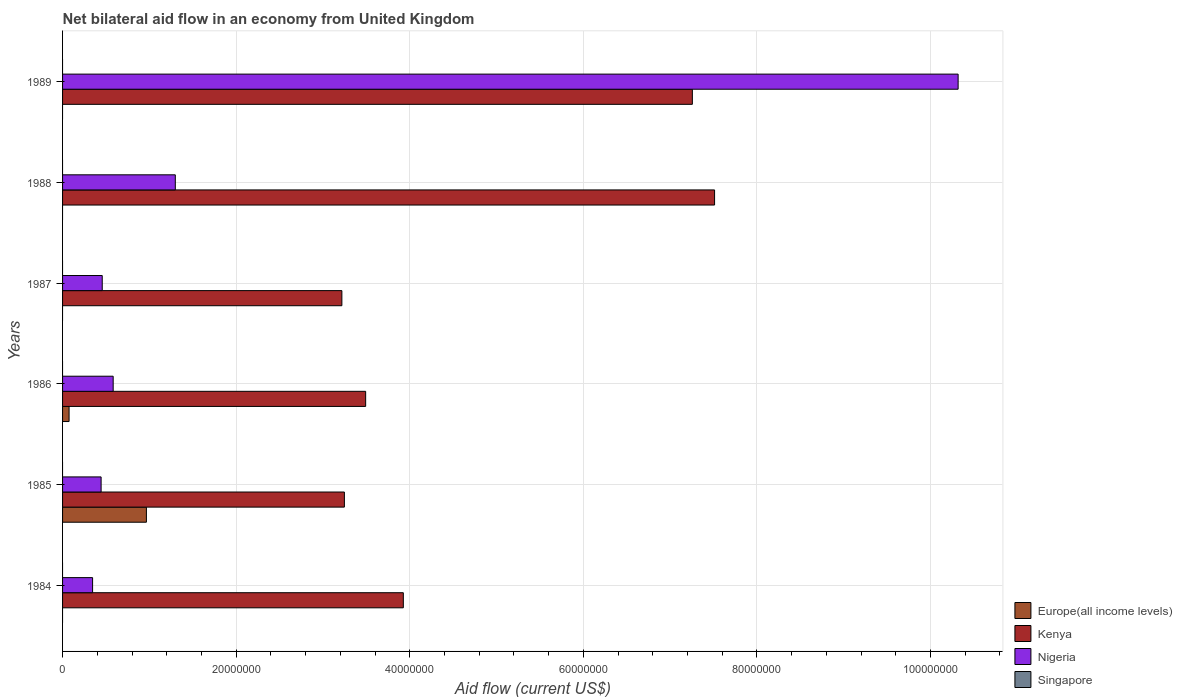How many different coloured bars are there?
Offer a very short reply. 3. How many groups of bars are there?
Keep it short and to the point. 6. Are the number of bars on each tick of the Y-axis equal?
Offer a terse response. No. Across all years, what is the maximum net bilateral aid flow in Kenya?
Your response must be concise. 7.51e+07. Across all years, what is the minimum net bilateral aid flow in Nigeria?
Give a very brief answer. 3.46e+06. What is the total net bilateral aid flow in Singapore in the graph?
Your answer should be compact. 0. What is the difference between the net bilateral aid flow in Nigeria in 1986 and that in 1988?
Your response must be concise. -7.16e+06. What is the difference between the net bilateral aid flow in Singapore in 1987 and the net bilateral aid flow in Kenya in 1988?
Make the answer very short. -7.51e+07. What is the average net bilateral aid flow in Nigeria per year?
Offer a terse response. 2.24e+07. In the year 1985, what is the difference between the net bilateral aid flow in Europe(all income levels) and net bilateral aid flow in Nigeria?
Your answer should be very brief. 5.22e+06. What is the ratio of the net bilateral aid flow in Nigeria in 1986 to that in 1989?
Make the answer very short. 0.06. What is the difference between the highest and the second highest net bilateral aid flow in Kenya?
Provide a succinct answer. 2.56e+06. What is the difference between the highest and the lowest net bilateral aid flow in Kenya?
Give a very brief answer. 4.29e+07. In how many years, is the net bilateral aid flow in Kenya greater than the average net bilateral aid flow in Kenya taken over all years?
Ensure brevity in your answer.  2. Is it the case that in every year, the sum of the net bilateral aid flow in Europe(all income levels) and net bilateral aid flow in Kenya is greater than the sum of net bilateral aid flow in Singapore and net bilateral aid flow in Nigeria?
Give a very brief answer. Yes. Are all the bars in the graph horizontal?
Your answer should be compact. Yes. How many years are there in the graph?
Provide a short and direct response. 6. Are the values on the major ticks of X-axis written in scientific E-notation?
Provide a short and direct response. No. Does the graph contain grids?
Make the answer very short. Yes. Where does the legend appear in the graph?
Offer a terse response. Bottom right. What is the title of the graph?
Ensure brevity in your answer.  Net bilateral aid flow in an economy from United Kingdom. What is the Aid flow (current US$) of Europe(all income levels) in 1984?
Make the answer very short. 0. What is the Aid flow (current US$) in Kenya in 1984?
Ensure brevity in your answer.  3.93e+07. What is the Aid flow (current US$) in Nigeria in 1984?
Ensure brevity in your answer.  3.46e+06. What is the Aid flow (current US$) of Singapore in 1984?
Offer a very short reply. 0. What is the Aid flow (current US$) in Europe(all income levels) in 1985?
Ensure brevity in your answer.  9.66e+06. What is the Aid flow (current US$) of Kenya in 1985?
Your answer should be compact. 3.25e+07. What is the Aid flow (current US$) of Nigeria in 1985?
Provide a succinct answer. 4.44e+06. What is the Aid flow (current US$) of Europe(all income levels) in 1986?
Your answer should be very brief. 7.50e+05. What is the Aid flow (current US$) in Kenya in 1986?
Offer a terse response. 3.49e+07. What is the Aid flow (current US$) of Nigeria in 1986?
Your answer should be compact. 5.83e+06. What is the Aid flow (current US$) of Europe(all income levels) in 1987?
Give a very brief answer. 0. What is the Aid flow (current US$) of Kenya in 1987?
Keep it short and to the point. 3.22e+07. What is the Aid flow (current US$) in Nigeria in 1987?
Your response must be concise. 4.57e+06. What is the Aid flow (current US$) of Kenya in 1988?
Provide a short and direct response. 7.51e+07. What is the Aid flow (current US$) of Nigeria in 1988?
Provide a short and direct response. 1.30e+07. What is the Aid flow (current US$) in Kenya in 1989?
Provide a succinct answer. 7.26e+07. What is the Aid flow (current US$) of Nigeria in 1989?
Keep it short and to the point. 1.03e+08. What is the Aid flow (current US$) of Singapore in 1989?
Offer a very short reply. 0. Across all years, what is the maximum Aid flow (current US$) of Europe(all income levels)?
Make the answer very short. 9.66e+06. Across all years, what is the maximum Aid flow (current US$) in Kenya?
Give a very brief answer. 7.51e+07. Across all years, what is the maximum Aid flow (current US$) in Nigeria?
Your answer should be compact. 1.03e+08. Across all years, what is the minimum Aid flow (current US$) in Europe(all income levels)?
Your answer should be very brief. 0. Across all years, what is the minimum Aid flow (current US$) of Kenya?
Keep it short and to the point. 3.22e+07. Across all years, what is the minimum Aid flow (current US$) in Nigeria?
Your answer should be compact. 3.46e+06. What is the total Aid flow (current US$) in Europe(all income levels) in the graph?
Offer a very short reply. 1.04e+07. What is the total Aid flow (current US$) of Kenya in the graph?
Offer a very short reply. 2.87e+08. What is the total Aid flow (current US$) in Nigeria in the graph?
Make the answer very short. 1.34e+08. What is the total Aid flow (current US$) in Singapore in the graph?
Give a very brief answer. 0. What is the difference between the Aid flow (current US$) in Kenya in 1984 and that in 1985?
Offer a terse response. 6.79e+06. What is the difference between the Aid flow (current US$) in Nigeria in 1984 and that in 1985?
Provide a succinct answer. -9.80e+05. What is the difference between the Aid flow (current US$) in Kenya in 1984 and that in 1986?
Offer a terse response. 4.34e+06. What is the difference between the Aid flow (current US$) of Nigeria in 1984 and that in 1986?
Your response must be concise. -2.37e+06. What is the difference between the Aid flow (current US$) in Kenya in 1984 and that in 1987?
Keep it short and to the point. 7.08e+06. What is the difference between the Aid flow (current US$) in Nigeria in 1984 and that in 1987?
Ensure brevity in your answer.  -1.11e+06. What is the difference between the Aid flow (current US$) in Kenya in 1984 and that in 1988?
Give a very brief answer. -3.59e+07. What is the difference between the Aid flow (current US$) in Nigeria in 1984 and that in 1988?
Provide a succinct answer. -9.53e+06. What is the difference between the Aid flow (current US$) of Kenya in 1984 and that in 1989?
Your answer should be very brief. -3.33e+07. What is the difference between the Aid flow (current US$) of Nigeria in 1984 and that in 1989?
Your response must be concise. -9.97e+07. What is the difference between the Aid flow (current US$) of Europe(all income levels) in 1985 and that in 1986?
Your response must be concise. 8.91e+06. What is the difference between the Aid flow (current US$) in Kenya in 1985 and that in 1986?
Make the answer very short. -2.45e+06. What is the difference between the Aid flow (current US$) of Nigeria in 1985 and that in 1986?
Offer a terse response. -1.39e+06. What is the difference between the Aid flow (current US$) in Kenya in 1985 and that in 1988?
Your answer should be very brief. -4.26e+07. What is the difference between the Aid flow (current US$) in Nigeria in 1985 and that in 1988?
Keep it short and to the point. -8.55e+06. What is the difference between the Aid flow (current US$) in Kenya in 1985 and that in 1989?
Ensure brevity in your answer.  -4.01e+07. What is the difference between the Aid flow (current US$) of Nigeria in 1985 and that in 1989?
Offer a terse response. -9.87e+07. What is the difference between the Aid flow (current US$) of Kenya in 1986 and that in 1987?
Your response must be concise. 2.74e+06. What is the difference between the Aid flow (current US$) in Nigeria in 1986 and that in 1987?
Your answer should be very brief. 1.26e+06. What is the difference between the Aid flow (current US$) in Kenya in 1986 and that in 1988?
Ensure brevity in your answer.  -4.02e+07. What is the difference between the Aid flow (current US$) of Nigeria in 1986 and that in 1988?
Give a very brief answer. -7.16e+06. What is the difference between the Aid flow (current US$) in Kenya in 1986 and that in 1989?
Give a very brief answer. -3.76e+07. What is the difference between the Aid flow (current US$) of Nigeria in 1986 and that in 1989?
Provide a succinct answer. -9.74e+07. What is the difference between the Aid flow (current US$) of Kenya in 1987 and that in 1988?
Provide a succinct answer. -4.29e+07. What is the difference between the Aid flow (current US$) in Nigeria in 1987 and that in 1988?
Make the answer very short. -8.42e+06. What is the difference between the Aid flow (current US$) in Kenya in 1987 and that in 1989?
Offer a terse response. -4.04e+07. What is the difference between the Aid flow (current US$) in Nigeria in 1987 and that in 1989?
Keep it short and to the point. -9.86e+07. What is the difference between the Aid flow (current US$) of Kenya in 1988 and that in 1989?
Offer a terse response. 2.56e+06. What is the difference between the Aid flow (current US$) in Nigeria in 1988 and that in 1989?
Offer a terse response. -9.02e+07. What is the difference between the Aid flow (current US$) in Kenya in 1984 and the Aid flow (current US$) in Nigeria in 1985?
Offer a very short reply. 3.48e+07. What is the difference between the Aid flow (current US$) of Kenya in 1984 and the Aid flow (current US$) of Nigeria in 1986?
Give a very brief answer. 3.34e+07. What is the difference between the Aid flow (current US$) of Kenya in 1984 and the Aid flow (current US$) of Nigeria in 1987?
Keep it short and to the point. 3.47e+07. What is the difference between the Aid flow (current US$) in Kenya in 1984 and the Aid flow (current US$) in Nigeria in 1988?
Your response must be concise. 2.63e+07. What is the difference between the Aid flow (current US$) in Kenya in 1984 and the Aid flow (current US$) in Nigeria in 1989?
Ensure brevity in your answer.  -6.39e+07. What is the difference between the Aid flow (current US$) in Europe(all income levels) in 1985 and the Aid flow (current US$) in Kenya in 1986?
Your answer should be compact. -2.53e+07. What is the difference between the Aid flow (current US$) of Europe(all income levels) in 1985 and the Aid flow (current US$) of Nigeria in 1986?
Provide a succinct answer. 3.83e+06. What is the difference between the Aid flow (current US$) of Kenya in 1985 and the Aid flow (current US$) of Nigeria in 1986?
Offer a terse response. 2.66e+07. What is the difference between the Aid flow (current US$) of Europe(all income levels) in 1985 and the Aid flow (current US$) of Kenya in 1987?
Provide a short and direct response. -2.25e+07. What is the difference between the Aid flow (current US$) of Europe(all income levels) in 1985 and the Aid flow (current US$) of Nigeria in 1987?
Offer a terse response. 5.09e+06. What is the difference between the Aid flow (current US$) in Kenya in 1985 and the Aid flow (current US$) in Nigeria in 1987?
Offer a very short reply. 2.79e+07. What is the difference between the Aid flow (current US$) of Europe(all income levels) in 1985 and the Aid flow (current US$) of Kenya in 1988?
Your answer should be very brief. -6.55e+07. What is the difference between the Aid flow (current US$) in Europe(all income levels) in 1985 and the Aid flow (current US$) in Nigeria in 1988?
Provide a succinct answer. -3.33e+06. What is the difference between the Aid flow (current US$) of Kenya in 1985 and the Aid flow (current US$) of Nigeria in 1988?
Offer a very short reply. 1.95e+07. What is the difference between the Aid flow (current US$) in Europe(all income levels) in 1985 and the Aid flow (current US$) in Kenya in 1989?
Offer a terse response. -6.29e+07. What is the difference between the Aid flow (current US$) in Europe(all income levels) in 1985 and the Aid flow (current US$) in Nigeria in 1989?
Your response must be concise. -9.35e+07. What is the difference between the Aid flow (current US$) in Kenya in 1985 and the Aid flow (current US$) in Nigeria in 1989?
Offer a very short reply. -7.07e+07. What is the difference between the Aid flow (current US$) in Europe(all income levels) in 1986 and the Aid flow (current US$) in Kenya in 1987?
Make the answer very short. -3.14e+07. What is the difference between the Aid flow (current US$) of Europe(all income levels) in 1986 and the Aid flow (current US$) of Nigeria in 1987?
Provide a short and direct response. -3.82e+06. What is the difference between the Aid flow (current US$) of Kenya in 1986 and the Aid flow (current US$) of Nigeria in 1987?
Keep it short and to the point. 3.04e+07. What is the difference between the Aid flow (current US$) of Europe(all income levels) in 1986 and the Aid flow (current US$) of Kenya in 1988?
Offer a very short reply. -7.44e+07. What is the difference between the Aid flow (current US$) in Europe(all income levels) in 1986 and the Aid flow (current US$) in Nigeria in 1988?
Provide a succinct answer. -1.22e+07. What is the difference between the Aid flow (current US$) in Kenya in 1986 and the Aid flow (current US$) in Nigeria in 1988?
Your answer should be very brief. 2.19e+07. What is the difference between the Aid flow (current US$) of Europe(all income levels) in 1986 and the Aid flow (current US$) of Kenya in 1989?
Give a very brief answer. -7.18e+07. What is the difference between the Aid flow (current US$) in Europe(all income levels) in 1986 and the Aid flow (current US$) in Nigeria in 1989?
Offer a terse response. -1.02e+08. What is the difference between the Aid flow (current US$) of Kenya in 1986 and the Aid flow (current US$) of Nigeria in 1989?
Offer a terse response. -6.83e+07. What is the difference between the Aid flow (current US$) of Kenya in 1987 and the Aid flow (current US$) of Nigeria in 1988?
Give a very brief answer. 1.92e+07. What is the difference between the Aid flow (current US$) in Kenya in 1987 and the Aid flow (current US$) in Nigeria in 1989?
Ensure brevity in your answer.  -7.10e+07. What is the difference between the Aid flow (current US$) in Kenya in 1988 and the Aid flow (current US$) in Nigeria in 1989?
Provide a short and direct response. -2.81e+07. What is the average Aid flow (current US$) in Europe(all income levels) per year?
Keep it short and to the point. 1.74e+06. What is the average Aid flow (current US$) in Kenya per year?
Keep it short and to the point. 4.78e+07. What is the average Aid flow (current US$) in Nigeria per year?
Offer a terse response. 2.24e+07. In the year 1984, what is the difference between the Aid flow (current US$) in Kenya and Aid flow (current US$) in Nigeria?
Give a very brief answer. 3.58e+07. In the year 1985, what is the difference between the Aid flow (current US$) of Europe(all income levels) and Aid flow (current US$) of Kenya?
Ensure brevity in your answer.  -2.28e+07. In the year 1985, what is the difference between the Aid flow (current US$) of Europe(all income levels) and Aid flow (current US$) of Nigeria?
Offer a terse response. 5.22e+06. In the year 1985, what is the difference between the Aid flow (current US$) in Kenya and Aid flow (current US$) in Nigeria?
Keep it short and to the point. 2.80e+07. In the year 1986, what is the difference between the Aid flow (current US$) of Europe(all income levels) and Aid flow (current US$) of Kenya?
Ensure brevity in your answer.  -3.42e+07. In the year 1986, what is the difference between the Aid flow (current US$) of Europe(all income levels) and Aid flow (current US$) of Nigeria?
Offer a very short reply. -5.08e+06. In the year 1986, what is the difference between the Aid flow (current US$) in Kenya and Aid flow (current US$) in Nigeria?
Offer a very short reply. 2.91e+07. In the year 1987, what is the difference between the Aid flow (current US$) in Kenya and Aid flow (current US$) in Nigeria?
Keep it short and to the point. 2.76e+07. In the year 1988, what is the difference between the Aid flow (current US$) of Kenya and Aid flow (current US$) of Nigeria?
Make the answer very short. 6.21e+07. In the year 1989, what is the difference between the Aid flow (current US$) of Kenya and Aid flow (current US$) of Nigeria?
Your answer should be compact. -3.06e+07. What is the ratio of the Aid flow (current US$) of Kenya in 1984 to that in 1985?
Keep it short and to the point. 1.21. What is the ratio of the Aid flow (current US$) of Nigeria in 1984 to that in 1985?
Your answer should be compact. 0.78. What is the ratio of the Aid flow (current US$) of Kenya in 1984 to that in 1986?
Keep it short and to the point. 1.12. What is the ratio of the Aid flow (current US$) of Nigeria in 1984 to that in 1986?
Provide a short and direct response. 0.59. What is the ratio of the Aid flow (current US$) of Kenya in 1984 to that in 1987?
Give a very brief answer. 1.22. What is the ratio of the Aid flow (current US$) in Nigeria in 1984 to that in 1987?
Offer a very short reply. 0.76. What is the ratio of the Aid flow (current US$) of Kenya in 1984 to that in 1988?
Give a very brief answer. 0.52. What is the ratio of the Aid flow (current US$) in Nigeria in 1984 to that in 1988?
Your answer should be very brief. 0.27. What is the ratio of the Aid flow (current US$) of Kenya in 1984 to that in 1989?
Provide a succinct answer. 0.54. What is the ratio of the Aid flow (current US$) of Nigeria in 1984 to that in 1989?
Keep it short and to the point. 0.03. What is the ratio of the Aid flow (current US$) in Europe(all income levels) in 1985 to that in 1986?
Your answer should be compact. 12.88. What is the ratio of the Aid flow (current US$) in Kenya in 1985 to that in 1986?
Offer a very short reply. 0.93. What is the ratio of the Aid flow (current US$) of Nigeria in 1985 to that in 1986?
Provide a succinct answer. 0.76. What is the ratio of the Aid flow (current US$) of Kenya in 1985 to that in 1987?
Your response must be concise. 1.01. What is the ratio of the Aid flow (current US$) of Nigeria in 1985 to that in 1987?
Your answer should be compact. 0.97. What is the ratio of the Aid flow (current US$) in Kenya in 1985 to that in 1988?
Your response must be concise. 0.43. What is the ratio of the Aid flow (current US$) of Nigeria in 1985 to that in 1988?
Your answer should be very brief. 0.34. What is the ratio of the Aid flow (current US$) in Kenya in 1985 to that in 1989?
Offer a terse response. 0.45. What is the ratio of the Aid flow (current US$) of Nigeria in 1985 to that in 1989?
Make the answer very short. 0.04. What is the ratio of the Aid flow (current US$) in Kenya in 1986 to that in 1987?
Provide a short and direct response. 1.09. What is the ratio of the Aid flow (current US$) of Nigeria in 1986 to that in 1987?
Your answer should be very brief. 1.28. What is the ratio of the Aid flow (current US$) of Kenya in 1986 to that in 1988?
Offer a terse response. 0.46. What is the ratio of the Aid flow (current US$) in Nigeria in 1986 to that in 1988?
Offer a very short reply. 0.45. What is the ratio of the Aid flow (current US$) of Kenya in 1986 to that in 1989?
Provide a short and direct response. 0.48. What is the ratio of the Aid flow (current US$) of Nigeria in 1986 to that in 1989?
Your answer should be very brief. 0.06. What is the ratio of the Aid flow (current US$) of Kenya in 1987 to that in 1988?
Give a very brief answer. 0.43. What is the ratio of the Aid flow (current US$) of Nigeria in 1987 to that in 1988?
Your response must be concise. 0.35. What is the ratio of the Aid flow (current US$) of Kenya in 1987 to that in 1989?
Offer a very short reply. 0.44. What is the ratio of the Aid flow (current US$) of Nigeria in 1987 to that in 1989?
Make the answer very short. 0.04. What is the ratio of the Aid flow (current US$) of Kenya in 1988 to that in 1989?
Make the answer very short. 1.04. What is the ratio of the Aid flow (current US$) of Nigeria in 1988 to that in 1989?
Offer a terse response. 0.13. What is the difference between the highest and the second highest Aid flow (current US$) of Kenya?
Your answer should be compact. 2.56e+06. What is the difference between the highest and the second highest Aid flow (current US$) of Nigeria?
Provide a succinct answer. 9.02e+07. What is the difference between the highest and the lowest Aid flow (current US$) in Europe(all income levels)?
Offer a very short reply. 9.66e+06. What is the difference between the highest and the lowest Aid flow (current US$) of Kenya?
Make the answer very short. 4.29e+07. What is the difference between the highest and the lowest Aid flow (current US$) of Nigeria?
Offer a very short reply. 9.97e+07. 